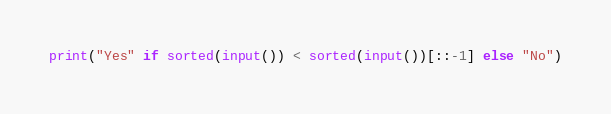<code> <loc_0><loc_0><loc_500><loc_500><_Python_>print("Yes" if sorted(input()) < sorted(input())[::-1] else "No")</code> 